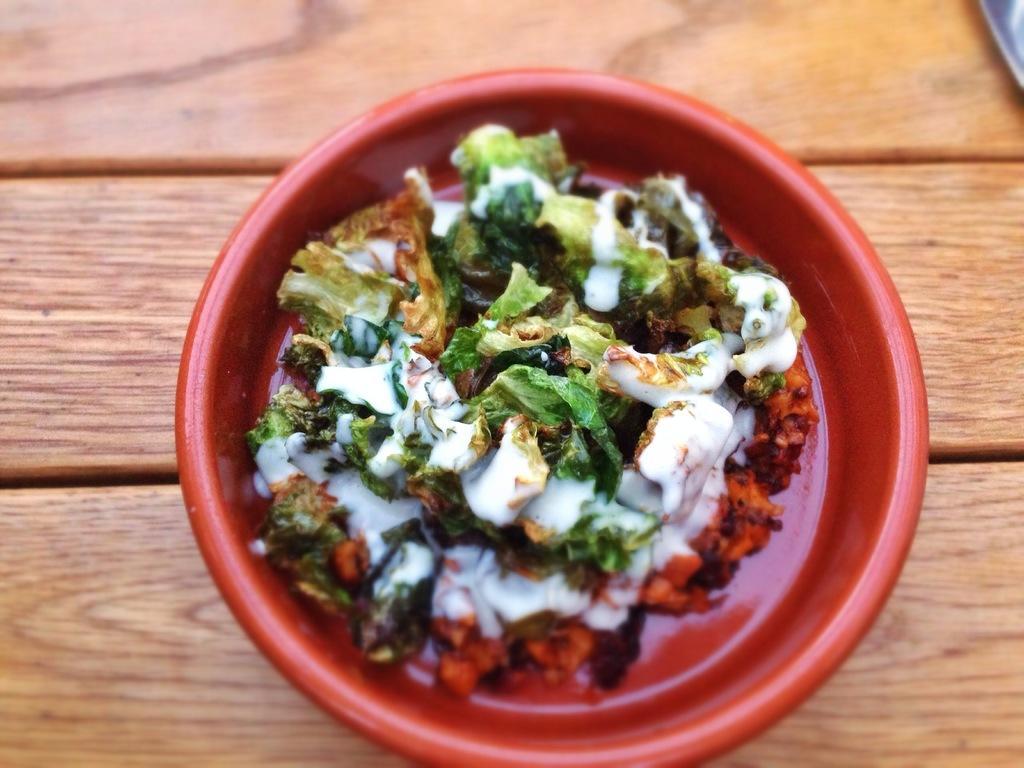Could you give a brief overview of what you see in this image? In this image we can see a food item in a red color bowl is on the wooden surface. 